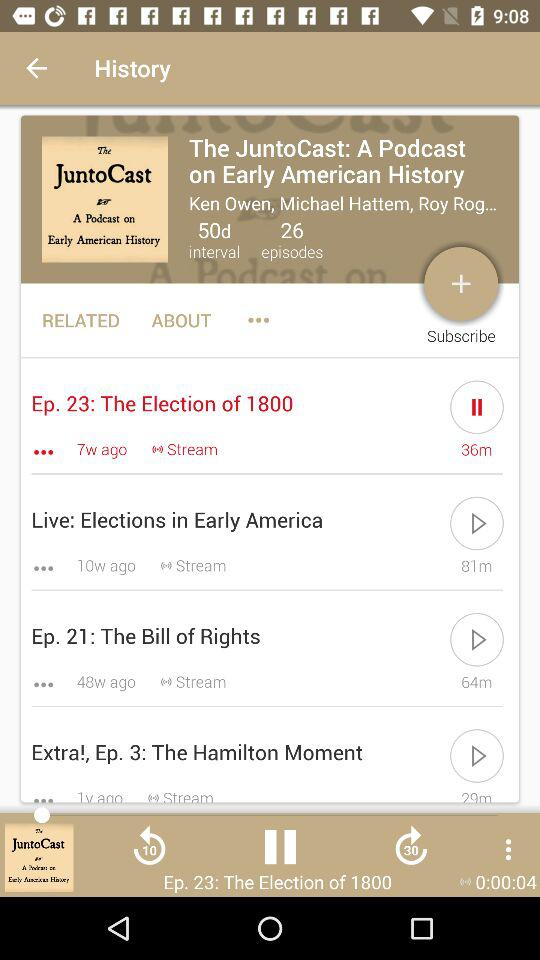How many episodes have a duration of more than 60 minutes?
Answer the question using a single word or phrase. 2 